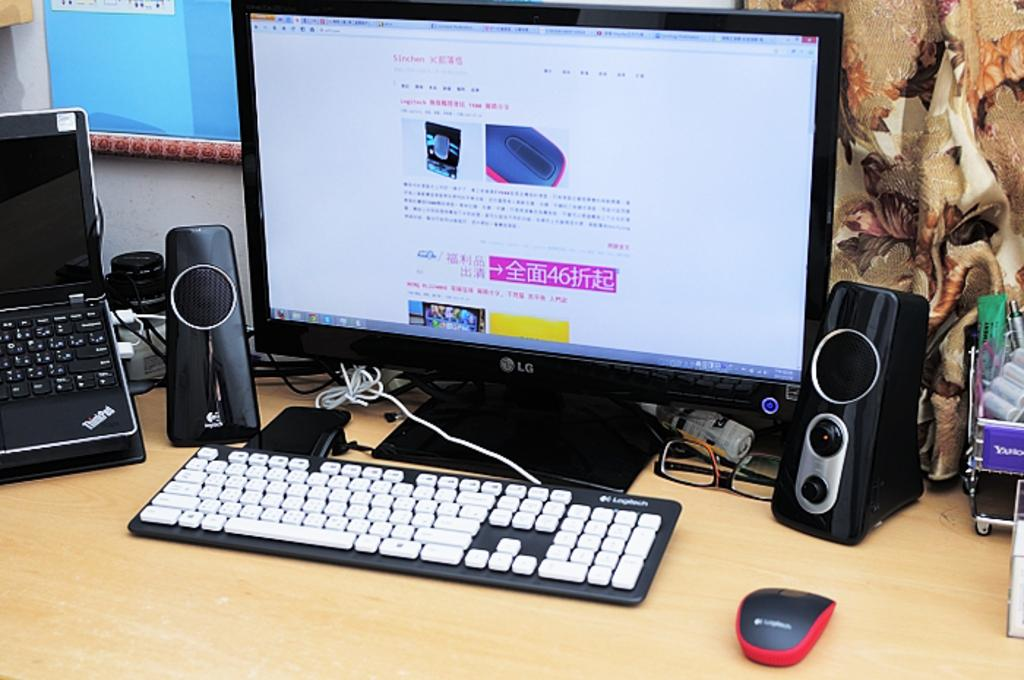<image>
Relay a brief, clear account of the picture shown. An LG monitor displays a website in a foreign language 